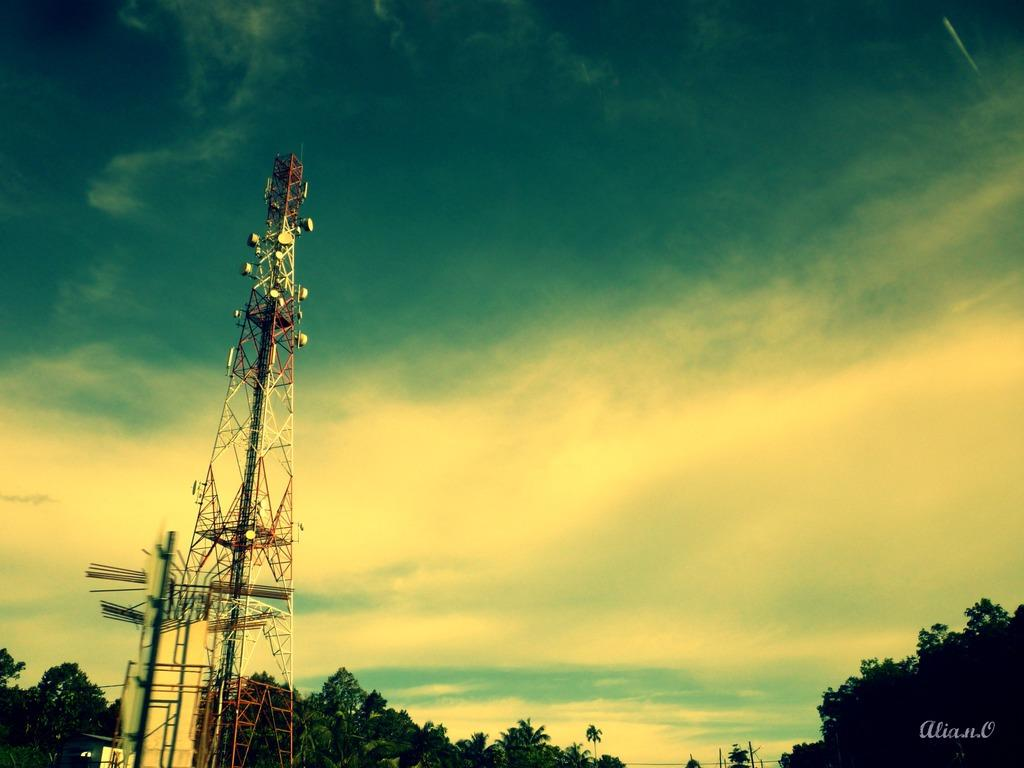What structure is located on the left side of the image? There is a tower on the left side of the image. What can be seen at the bottom of the image? There are trees and wires at the bottom of the image. What is visible at the top of the image? The sky is visible at the top of the image. What type of lace can be seen tied in a knot at the top of the tower in the image? There is no lace or knot present at the top of the tower in the image. Are there any trains visible in the image? There are no trains present in the image. 